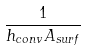Convert formula to latex. <formula><loc_0><loc_0><loc_500><loc_500>\frac { 1 } { h _ { c o n v } A _ { s u r f } }</formula> 